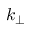<formula> <loc_0><loc_0><loc_500><loc_500>k _ { \perp }</formula> 